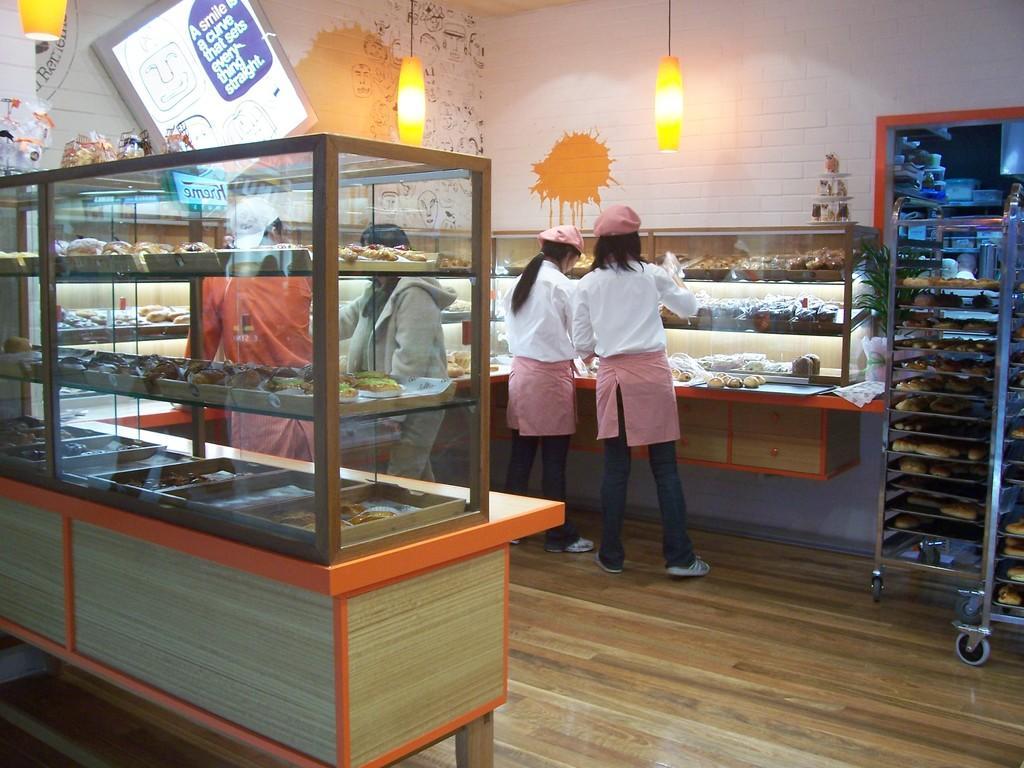Describe this image in one or two sentences. In this image I can see different types of food on the glass shelves. In the centre I can see four persons are standing. On the top side of this image I can see three lights and a board on the wall. 